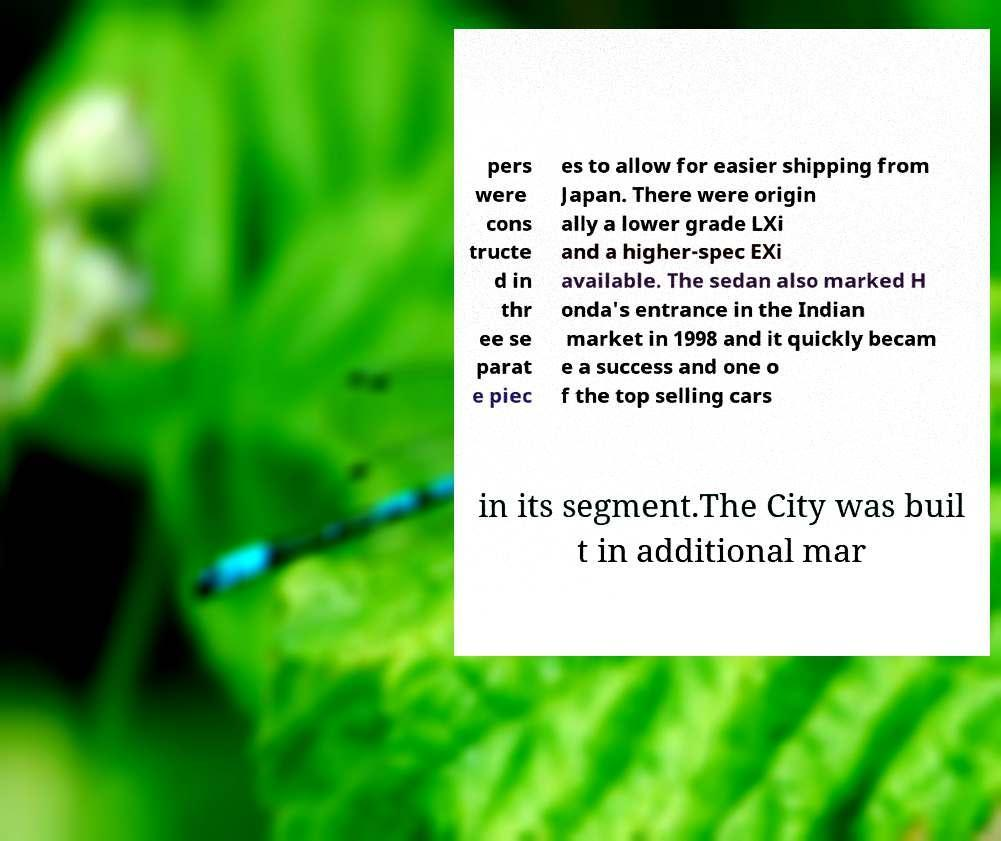I need the written content from this picture converted into text. Can you do that? pers were cons tructe d in thr ee se parat e piec es to allow for easier shipping from Japan. There were origin ally a lower grade LXi and a higher-spec EXi available. The sedan also marked H onda's entrance in the Indian market in 1998 and it quickly becam e a success and one o f the top selling cars in its segment.The City was buil t in additional mar 